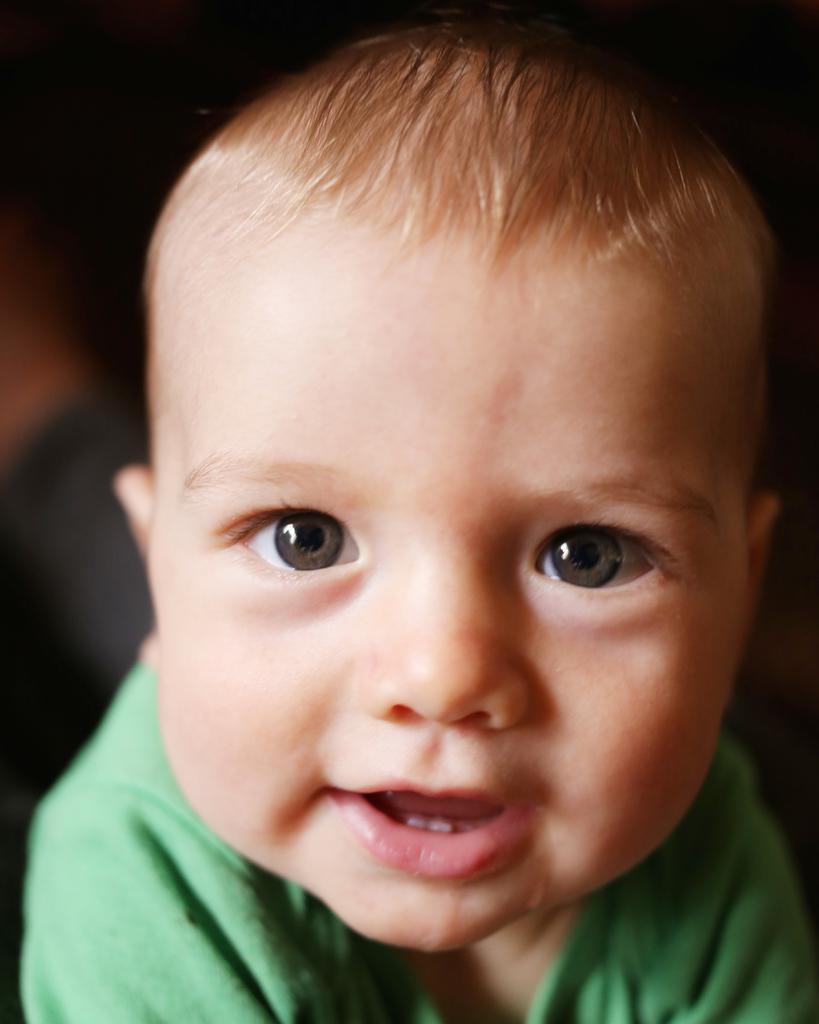Please provide a concise description of this image. In this image there is a boy smiling , and there is blur background. 